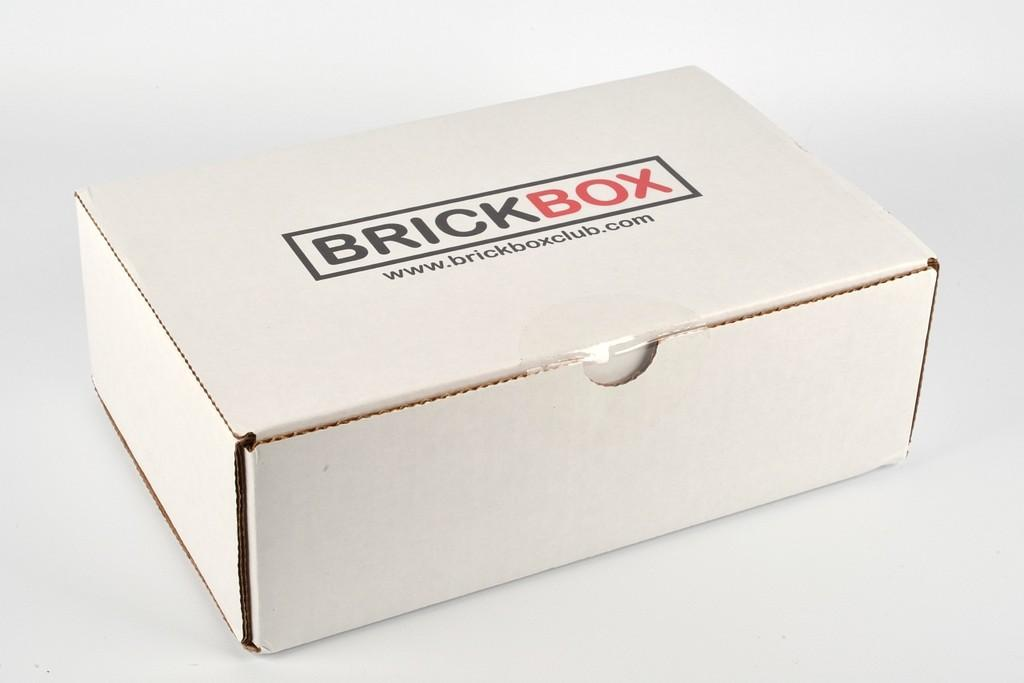<image>
Summarize the visual content of the image. BRICKBOX is printed on a white box that lays by itself. 